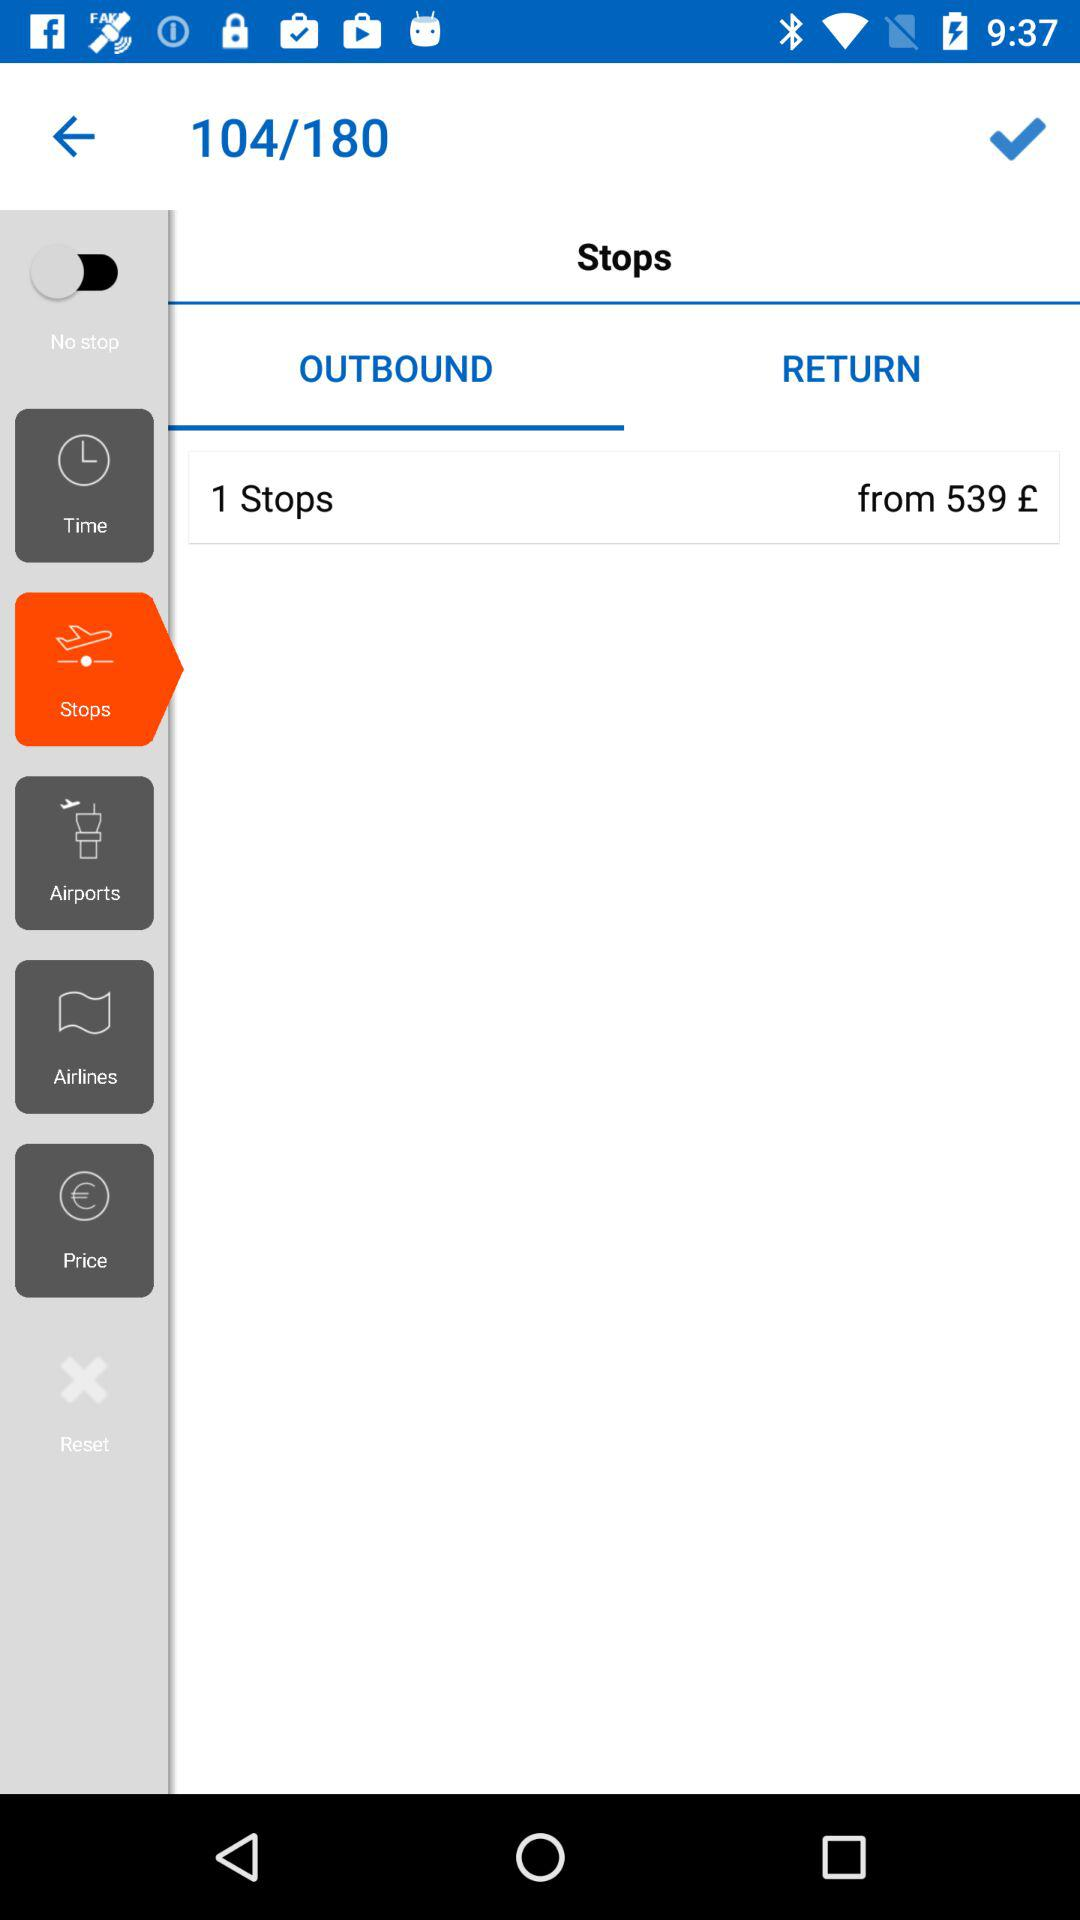How many notifications are there in "Price"?
When the provided information is insufficient, respond with <no answer>. <no answer> 